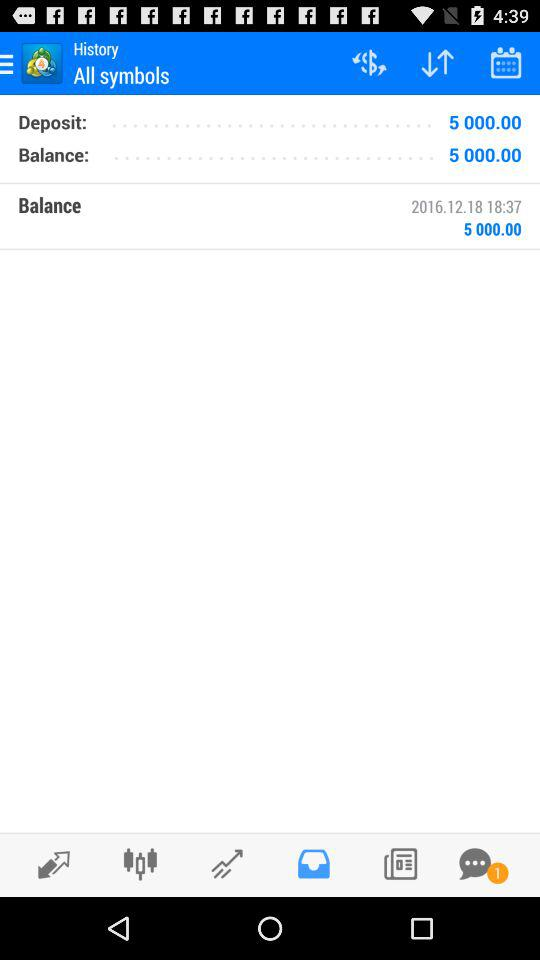How many unread messages are there? There is 1 unread message. 